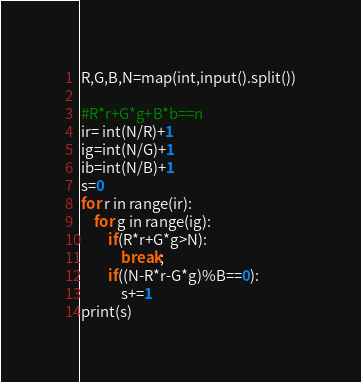<code> <loc_0><loc_0><loc_500><loc_500><_Python_>R,G,B,N=map(int,input().split())

#R*r+G*g+B*b==n
ir= int(N/R)+1
ig=int(N/G)+1
ib=int(N/B)+1
s=0
for r in range(ir):
    for g in range(ig):
        if(R*r+G*g>N):
            break;
        if((N-R*r-G*g)%B==0):
            s+=1
print(s)
</code> 